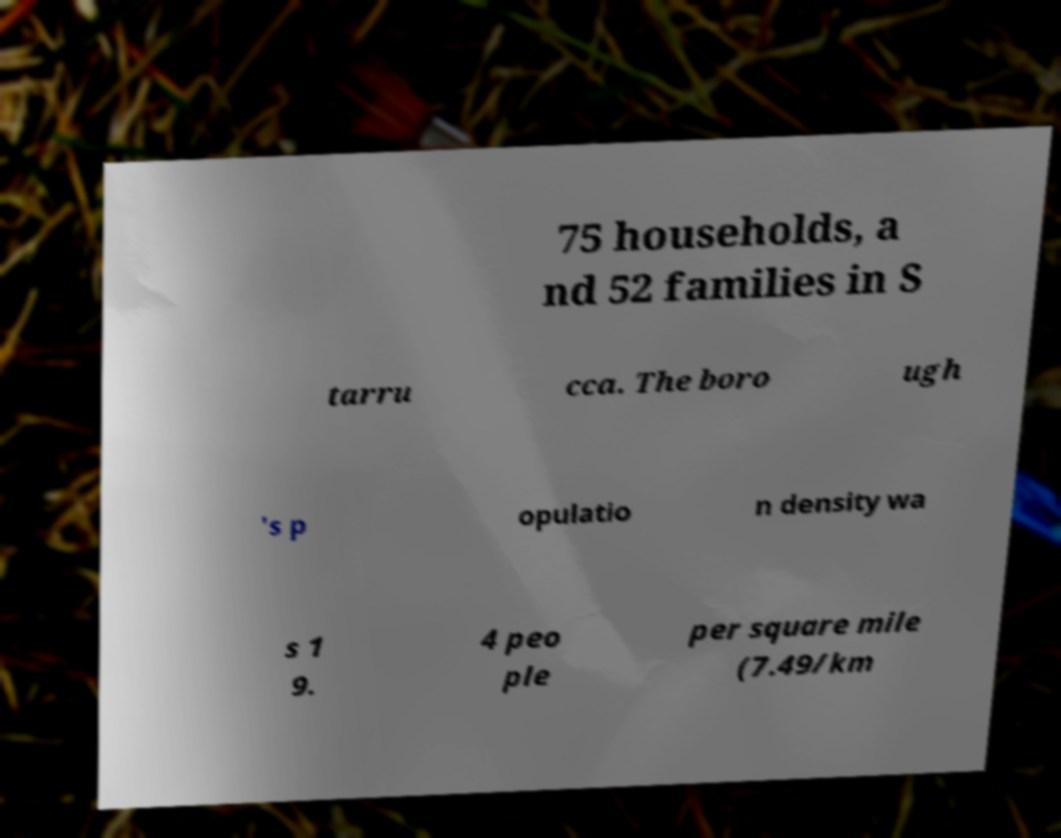Could you assist in decoding the text presented in this image and type it out clearly? 75 households, a nd 52 families in S tarru cca. The boro ugh 's p opulatio n density wa s 1 9. 4 peo ple per square mile (7.49/km 